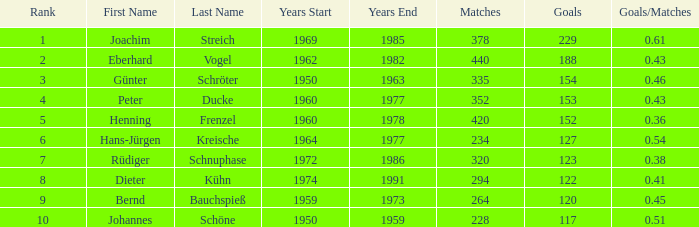How many goals/games have 153 as the goals with games exceeding 352? None. 